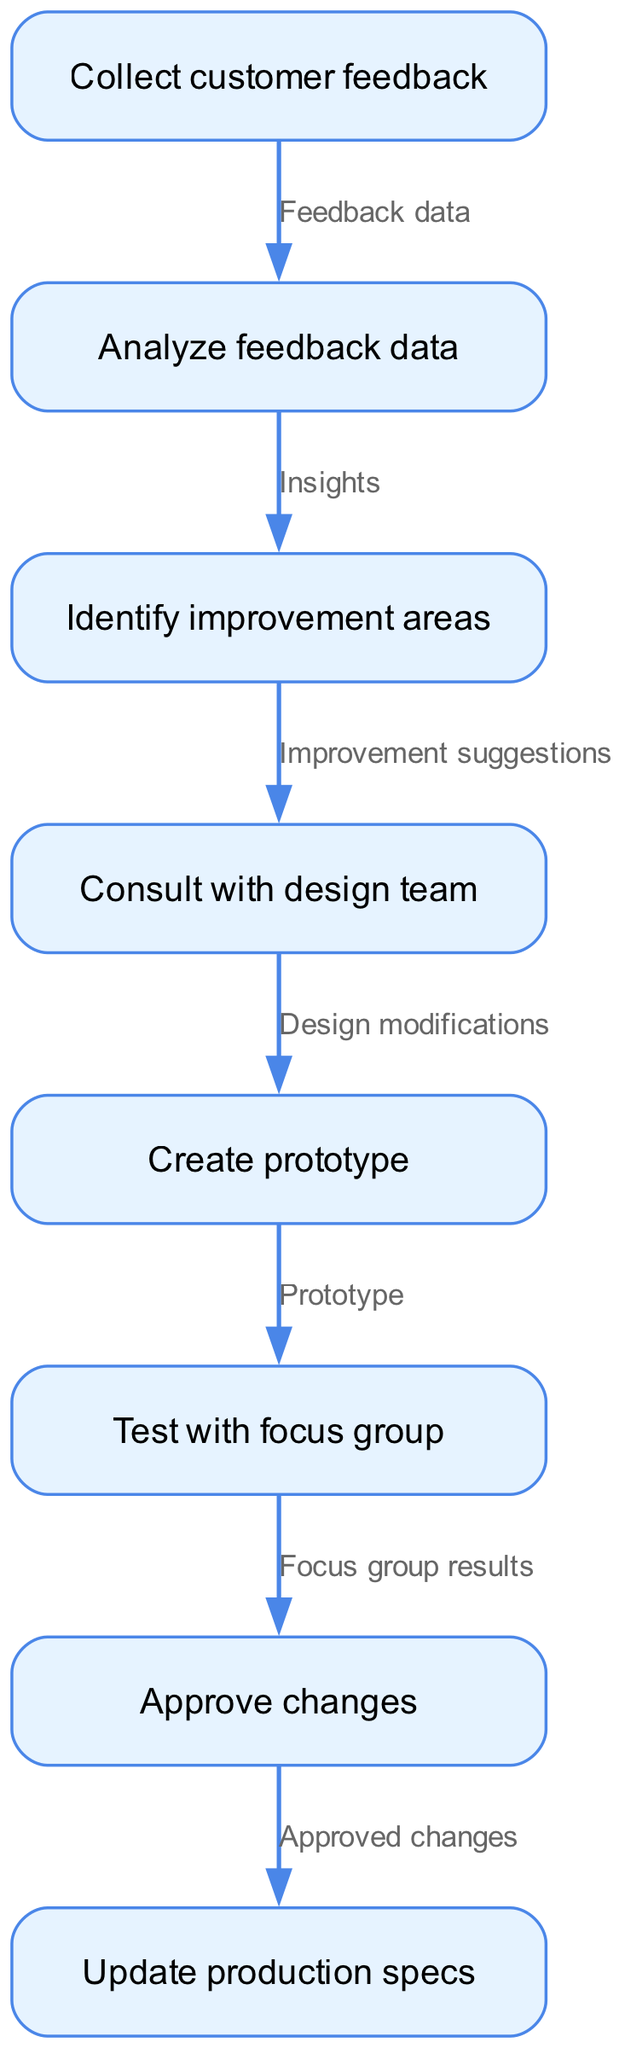What is the first step in the feedback integration process? The first node in the diagram is labeled "Collect customer feedback," indicating that this is the starting point of the process.
Answer: Collect customer feedback How many nodes are there in the diagram? By counting the JSON data provided, there are eight distinct nodes listed in the "nodes" array of the data.
Answer: 8 What feedback is analyzed following feedback collection? According to the flowchart, after collecting customer feedback, the next step is "Analyze feedback data," which indicates the type of feedback being analyzed.
Answer: Analyze feedback data What process comes before creating a prototype? The flowchart indicates that after consulting with the design team, the next step is to "Create prototype," meaning consulting is the preceding process.
Answer: Consult with design team What is the final step before updating production specifications? According to the edges in the diagram, the last step before updating production specs is "Approve changes," making it the final step in this path.
Answer: Approve changes How are improvement areas identified? Improvement areas are identified after analyzing feedback data, as shown in the diagram, indicating that insights from the analysis lead to this identification.
Answer: Insights What type of results are tested with a focus group? The flowchart shows that the prototype created is tested with a focus group, specifying the type of results involved in this testing step.
Answer: Prototype What connects the “Identify improvement areas” to “Consult with design team”? The flowchart indicates that the edge labeled "Improvement suggestions" connects these two nodes, representing the relationship between them.
Answer: Improvement suggestions 